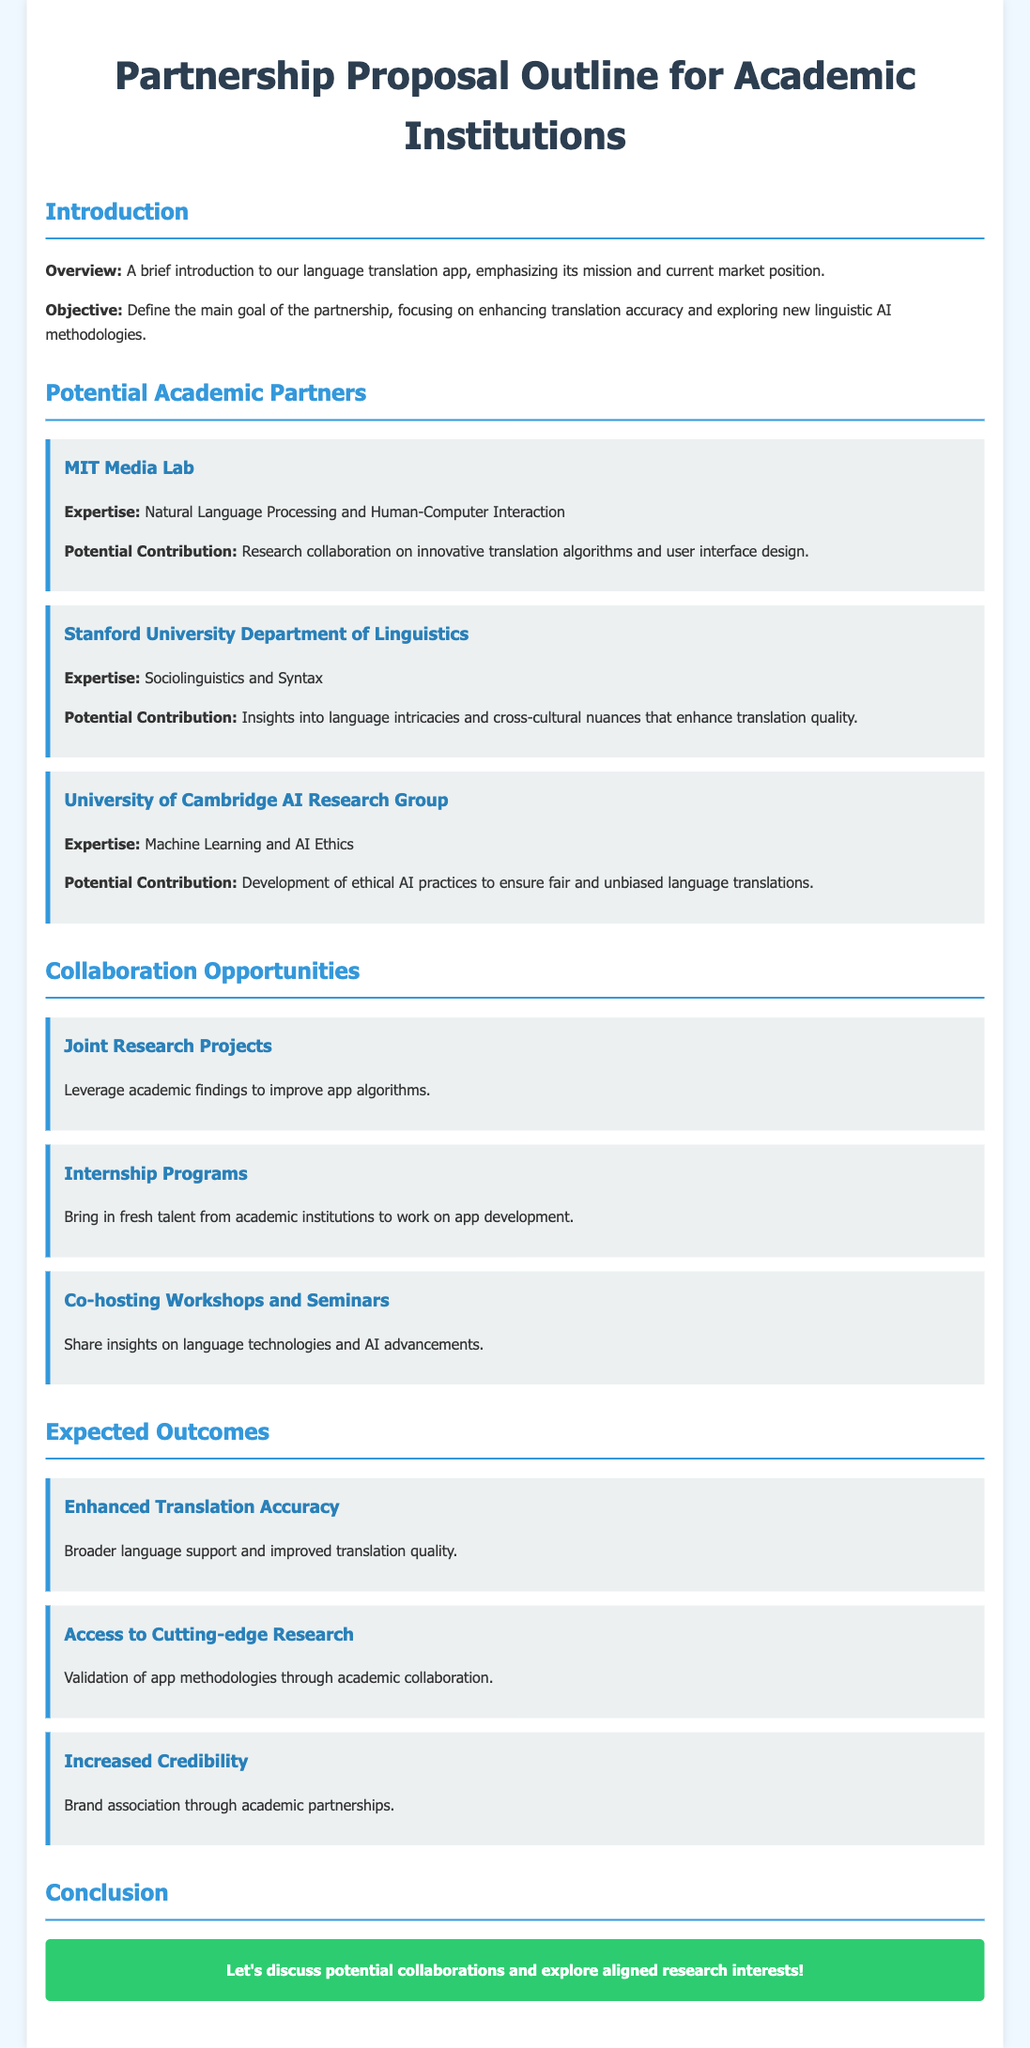What is the main goal of the partnership? The main goal of the partnership is to enhance translation accuracy and explore new linguistic AI methodologies.
Answer: Enhance translation accuracy and explore new linguistic AI methodologies Which institution focuses on Natural Language Processing? The institution that focuses on Natural Language Processing is MIT Media Lab.
Answer: MIT Media Lab What are the two expected outcomes related to research? The two expected outcomes related to research are enhanced translation accuracy and access to cutting-edge research.
Answer: Enhanced translation accuracy and access to cutting-edge research How many collaboration opportunities are mentioned? There are three collaboration opportunities mentioned in the document.
Answer: Three What type of seminar is suggested to co-host? The suggested seminar to co-host is on language technologies and AI advancements.
Answer: Language technologies and AI advancements What is the expertise of the University of Cambridge AI Research Group? The expertise of the University of Cambridge AI Research Group is Machine Learning and AI Ethics.
Answer: Machine Learning and AI Ethics 